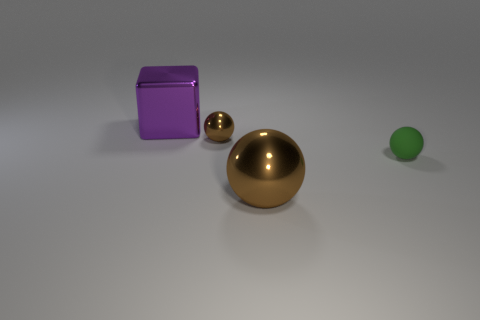Subtract all brown spheres. How many spheres are left? 1 Subtract all yellow cubes. How many brown balls are left? 2 Add 4 tiny gray metal things. How many objects exist? 8 Add 1 small brown metal balls. How many small brown metal balls exist? 2 Subtract 0 green cylinders. How many objects are left? 4 Subtract all balls. How many objects are left? 1 Subtract all big blue metallic cubes. Subtract all green matte objects. How many objects are left? 3 Add 4 large brown metallic balls. How many large brown metallic balls are left? 5 